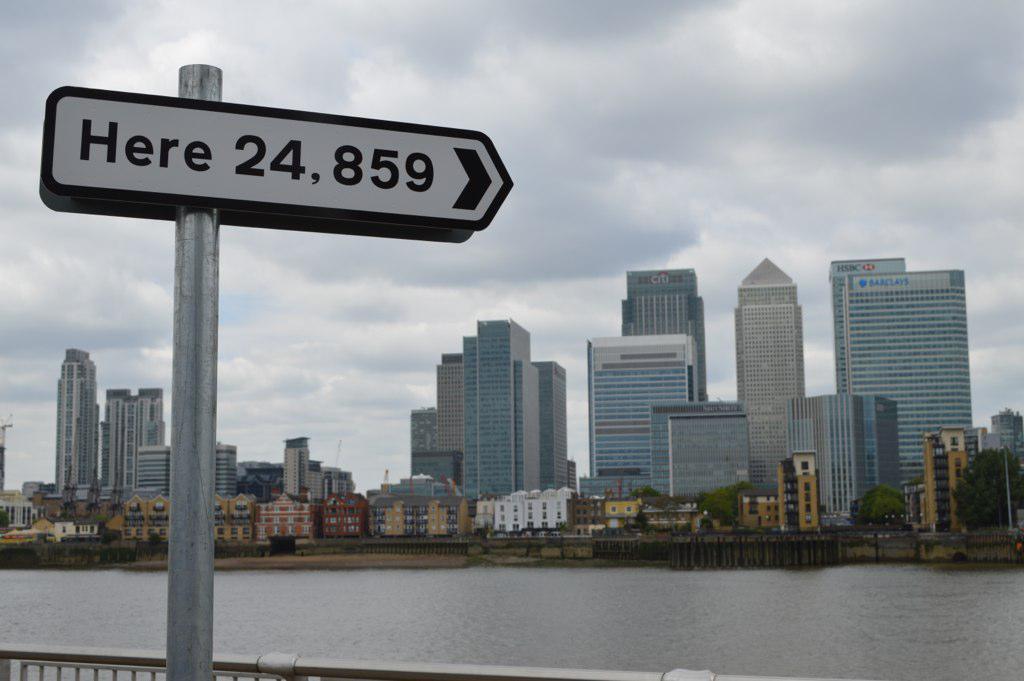Describe this image in one or two sentences. In this image there is a pole on the left side to which there is a directional board. At the bottom it looks like a lake. In the middle there are so many tall buildings one beside the other. At the top there is the sky. At the bottom it looks like a fence. 